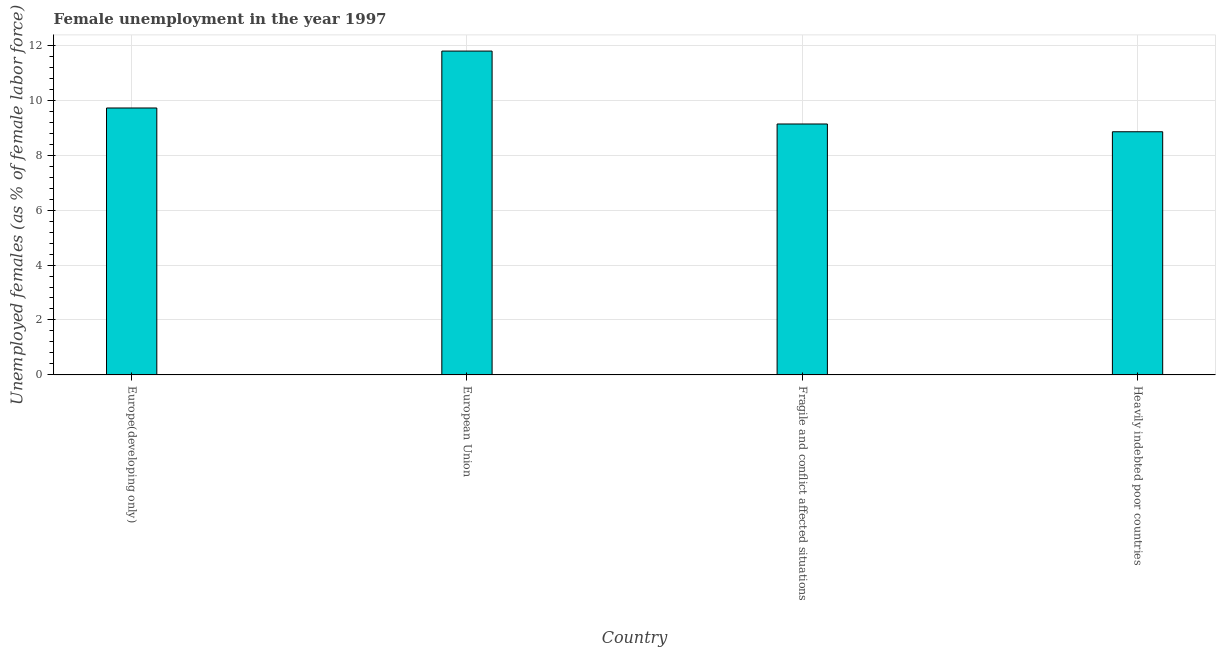What is the title of the graph?
Offer a terse response. Female unemployment in the year 1997. What is the label or title of the Y-axis?
Your answer should be compact. Unemployed females (as % of female labor force). What is the unemployed females population in Heavily indebted poor countries?
Give a very brief answer. 8.85. Across all countries, what is the maximum unemployed females population?
Your response must be concise. 11.79. Across all countries, what is the minimum unemployed females population?
Provide a short and direct response. 8.85. In which country was the unemployed females population maximum?
Your answer should be compact. European Union. In which country was the unemployed females population minimum?
Offer a very short reply. Heavily indebted poor countries. What is the sum of the unemployed females population?
Give a very brief answer. 39.49. What is the difference between the unemployed females population in Europe(developing only) and Fragile and conflict affected situations?
Your answer should be compact. 0.58. What is the average unemployed females population per country?
Ensure brevity in your answer.  9.87. What is the median unemployed females population?
Offer a very short reply. 9.43. In how many countries, is the unemployed females population greater than 11.2 %?
Offer a terse response. 1. What is the ratio of the unemployed females population in Fragile and conflict affected situations to that in Heavily indebted poor countries?
Make the answer very short. 1.03. What is the difference between the highest and the second highest unemployed females population?
Your response must be concise. 2.07. Is the sum of the unemployed females population in Fragile and conflict affected situations and Heavily indebted poor countries greater than the maximum unemployed females population across all countries?
Your response must be concise. Yes. What is the difference between the highest and the lowest unemployed females population?
Ensure brevity in your answer.  2.94. How many bars are there?
Offer a terse response. 4. How many countries are there in the graph?
Keep it short and to the point. 4. What is the difference between two consecutive major ticks on the Y-axis?
Offer a terse response. 2. Are the values on the major ticks of Y-axis written in scientific E-notation?
Your answer should be very brief. No. What is the Unemployed females (as % of female labor force) of Europe(developing only)?
Provide a short and direct response. 9.72. What is the Unemployed females (as % of female labor force) in European Union?
Provide a succinct answer. 11.79. What is the Unemployed females (as % of female labor force) in Fragile and conflict affected situations?
Offer a very short reply. 9.13. What is the Unemployed females (as % of female labor force) of Heavily indebted poor countries?
Ensure brevity in your answer.  8.85. What is the difference between the Unemployed females (as % of female labor force) in Europe(developing only) and European Union?
Keep it short and to the point. -2.07. What is the difference between the Unemployed females (as % of female labor force) in Europe(developing only) and Fragile and conflict affected situations?
Offer a very short reply. 0.58. What is the difference between the Unemployed females (as % of female labor force) in Europe(developing only) and Heavily indebted poor countries?
Keep it short and to the point. 0.86. What is the difference between the Unemployed females (as % of female labor force) in European Union and Fragile and conflict affected situations?
Your answer should be very brief. 2.65. What is the difference between the Unemployed females (as % of female labor force) in European Union and Heavily indebted poor countries?
Make the answer very short. 2.94. What is the difference between the Unemployed females (as % of female labor force) in Fragile and conflict affected situations and Heavily indebted poor countries?
Provide a succinct answer. 0.28. What is the ratio of the Unemployed females (as % of female labor force) in Europe(developing only) to that in European Union?
Offer a terse response. 0.82. What is the ratio of the Unemployed females (as % of female labor force) in Europe(developing only) to that in Fragile and conflict affected situations?
Offer a terse response. 1.06. What is the ratio of the Unemployed females (as % of female labor force) in Europe(developing only) to that in Heavily indebted poor countries?
Provide a short and direct response. 1.1. What is the ratio of the Unemployed females (as % of female labor force) in European Union to that in Fragile and conflict affected situations?
Keep it short and to the point. 1.29. What is the ratio of the Unemployed females (as % of female labor force) in European Union to that in Heavily indebted poor countries?
Make the answer very short. 1.33. What is the ratio of the Unemployed females (as % of female labor force) in Fragile and conflict affected situations to that in Heavily indebted poor countries?
Keep it short and to the point. 1.03. 